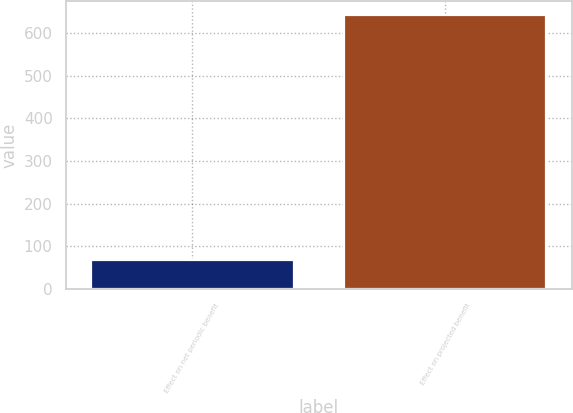Convert chart to OTSL. <chart><loc_0><loc_0><loc_500><loc_500><bar_chart><fcel>Effect on net periodic benefit<fcel>Effect on projected benefit<nl><fcel>67<fcel>643<nl></chart> 